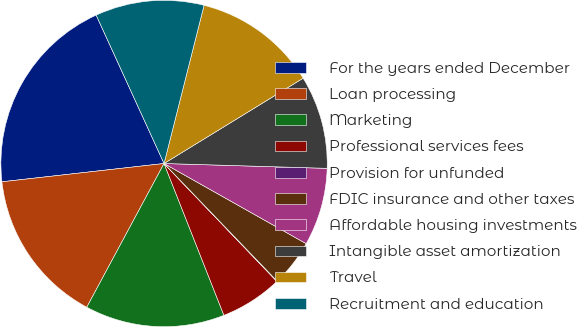Convert chart. <chart><loc_0><loc_0><loc_500><loc_500><pie_chart><fcel>For the years ended December<fcel>Loan processing<fcel>Marketing<fcel>Professional services fees<fcel>Provision for unfunded<fcel>FDIC insurance and other taxes<fcel>Affordable housing investments<fcel>Intangible asset amortization<fcel>Travel<fcel>Recruitment and education<nl><fcel>19.96%<fcel>15.36%<fcel>13.83%<fcel>6.17%<fcel>0.04%<fcel>4.64%<fcel>7.7%<fcel>9.23%<fcel>12.3%<fcel>10.77%<nl></chart> 